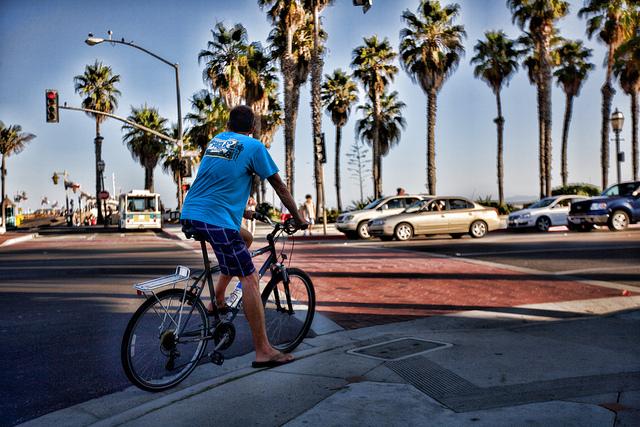How many police cars are in this picture?
Keep it brief. 0. Is everyone biking towards the water?
Keep it brief. No. How many cars are there?
Quick response, please. 4. Is the guy on the bike going to the beach?
Concise answer only. Yes. What kind of pants is the man wearing?
Keep it brief. Shorts. What type of trees are lining the street?
Quick response, please. Palm. What is the weather like?
Answer briefly. Sunny. What is the thin part that is touching the ground in the middle of the vehicle?
Quick response, please. Tire. How many bikes are there?
Short answer required. 1. 